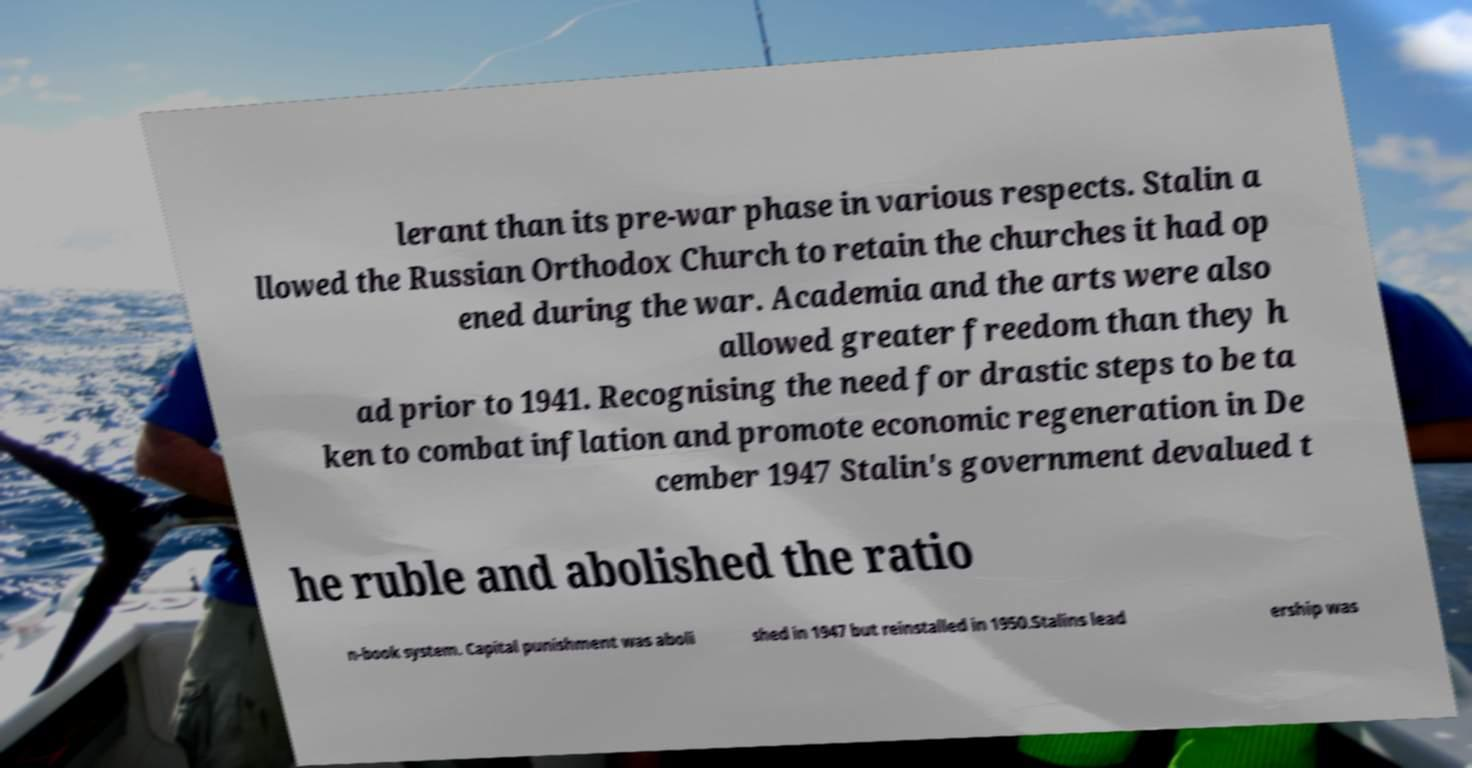I need the written content from this picture converted into text. Can you do that? lerant than its pre-war phase in various respects. Stalin a llowed the Russian Orthodox Church to retain the churches it had op ened during the war. Academia and the arts were also allowed greater freedom than they h ad prior to 1941. Recognising the need for drastic steps to be ta ken to combat inflation and promote economic regeneration in De cember 1947 Stalin's government devalued t he ruble and abolished the ratio n-book system. Capital punishment was aboli shed in 1947 but reinstalled in 1950.Stalins lead ership was 